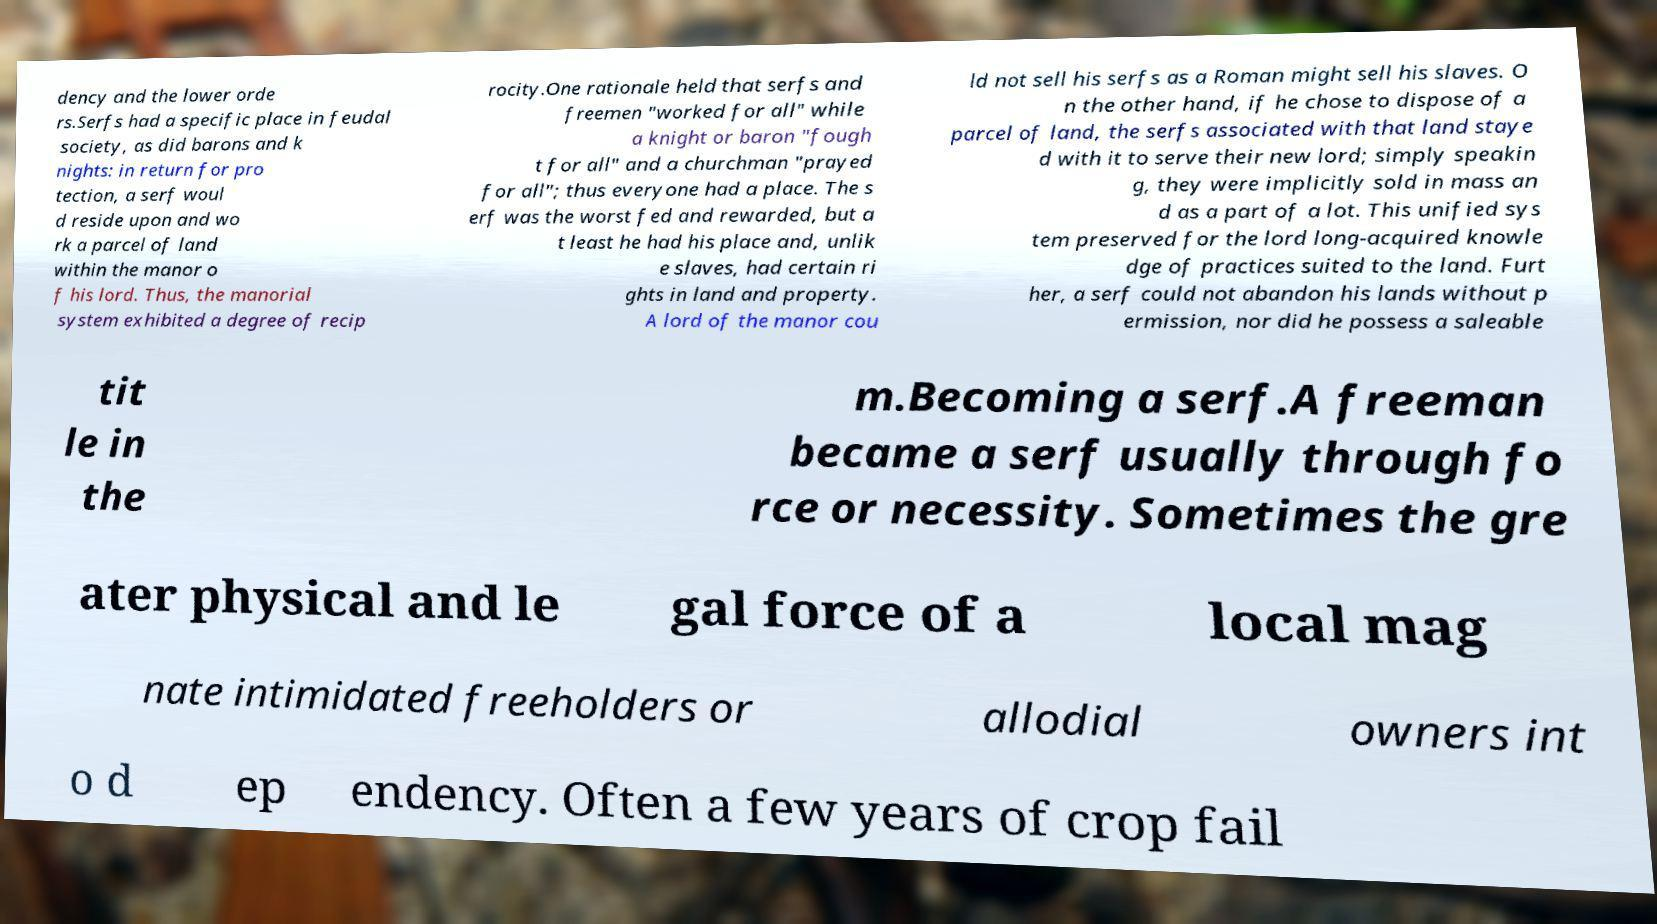Can you read and provide the text displayed in the image?This photo seems to have some interesting text. Can you extract and type it out for me? dency and the lower orde rs.Serfs had a specific place in feudal society, as did barons and k nights: in return for pro tection, a serf woul d reside upon and wo rk a parcel of land within the manor o f his lord. Thus, the manorial system exhibited a degree of recip rocity.One rationale held that serfs and freemen "worked for all" while a knight or baron "fough t for all" and a churchman "prayed for all"; thus everyone had a place. The s erf was the worst fed and rewarded, but a t least he had his place and, unlik e slaves, had certain ri ghts in land and property. A lord of the manor cou ld not sell his serfs as a Roman might sell his slaves. O n the other hand, if he chose to dispose of a parcel of land, the serfs associated with that land staye d with it to serve their new lord; simply speakin g, they were implicitly sold in mass an d as a part of a lot. This unified sys tem preserved for the lord long-acquired knowle dge of practices suited to the land. Furt her, a serf could not abandon his lands without p ermission, nor did he possess a saleable tit le in the m.Becoming a serf.A freeman became a serf usually through fo rce or necessity. Sometimes the gre ater physical and le gal force of a local mag nate intimidated freeholders or allodial owners int o d ep endency. Often a few years of crop fail 